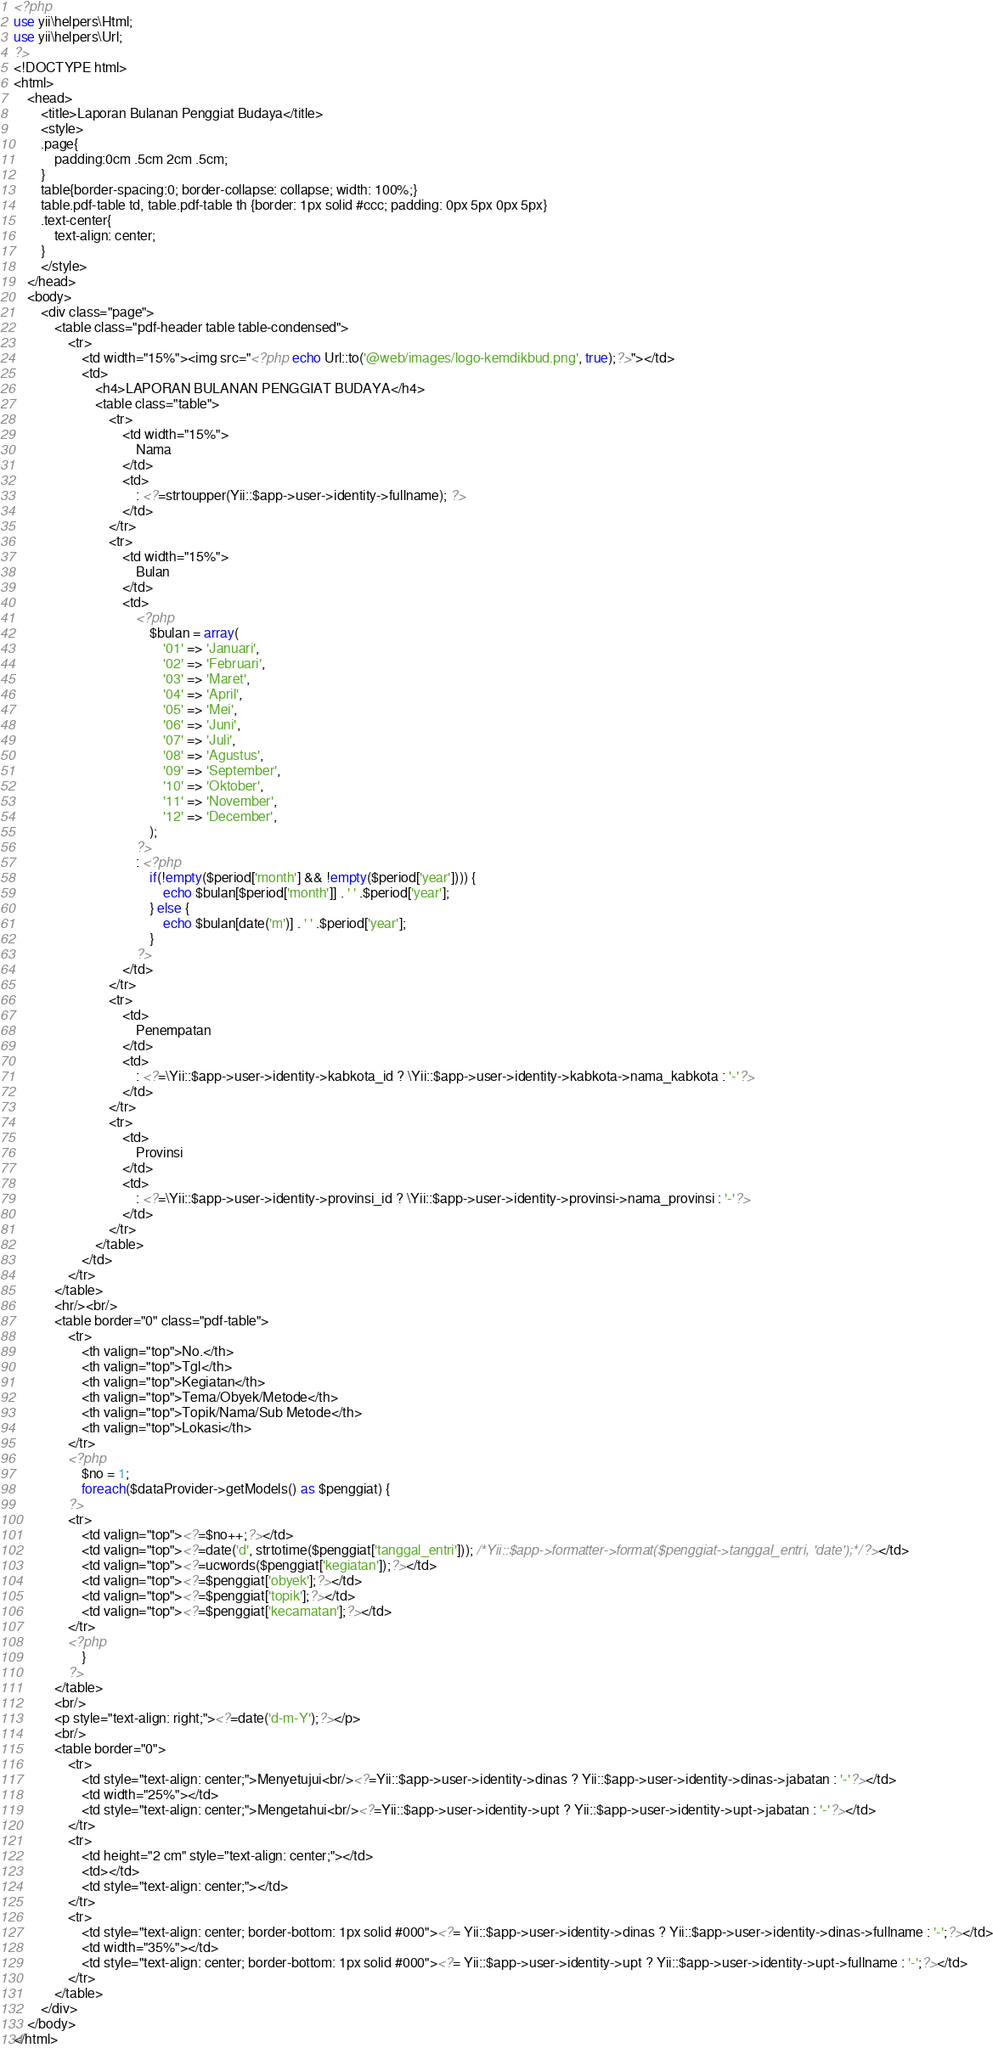Convert code to text. <code><loc_0><loc_0><loc_500><loc_500><_PHP_><?php
use yii\helpers\Html;
use yii\helpers\Url;
?>
<!DOCTYPE html>
<html>
    <head>
        <title>Laporan Bulanan Penggiat Budaya</title>
        <style>
        .page{
            padding:0cm .5cm 2cm .5cm;
        }
        table{border-spacing:0; border-collapse: collapse; width: 100%;}
        table.pdf-table td, table.pdf-table th {border: 1px solid #ccc; padding: 0px 5px 0px 5px}
        .text-center{
            text-align: center;
        }
        </style>
    </head>
    <body>
        <div class="page">
            <table class="pdf-header table table-condensed">
                <tr>
                    <td width="15%"><img src="<?php echo Url::to('@web/images/logo-kemdikbud.png', true);?>"></td>
                    <td>
                        <h4>LAPORAN BULANAN PENGGIAT BUDAYA</h4>
                        <table class="table">
                            <tr>
                                <td width="15%">
                                    Nama
                                </td>
                                <td>
                                    : <?=strtoupper(Yii::$app->user->identity->fullname); ?>
                                </td>
                            </tr>
                            <tr>
                                <td width="15%">
                                    Bulan
                                </td>
                                <td>
                                    <?php
                                        $bulan = array(
                                            '01' => 'Januari',
                                            '02' => 'Februari',
                                            '03' => 'Maret',
                                            '04' => 'April',
                                            '05' => 'Mei',
                                            '06' => 'Juni',
                                            '07' => 'Juli',
                                            '08' => 'Agustus',
                                            '09' => 'September',
                                            '10' => 'Oktober',
                                            '11' => 'November',
                                            '12' => 'December',
                                        );
                                    ?>
                                    : <?php
                                        if(!empty($period['month'] && !empty($period['year']))) {
                                            echo $bulan[$period['month']] . ' ' .$period['year'];
                                        } else {
                                            echo $bulan[date('m')] . ' ' .$period['year'];
                                        }
                                    ?>
                                </td>
                            </tr>
                            <tr>
                                <td>
                                    Penempatan
                                </td>
                                <td>
                                    : <?=\Yii::$app->user->identity->kabkota_id ? \Yii::$app->user->identity->kabkota->nama_kabkota : '-'?>
                                </td>
                            </tr>
                            <tr>
                                <td>
                                    Provinsi
                                </td>
                                <td>
                                    : <?=\Yii::$app->user->identity->provinsi_id ? \Yii::$app->user->identity->provinsi->nama_provinsi : '-'?>
                                </td>
                            </tr>
                        </table>
                    </td>
                </tr>
            </table>
            <hr/><br/>
            <table border="0" class="pdf-table">
                <tr>
                    <th valign="top">No.</th>
                    <th valign="top">Tgl</th>
                    <th valign="top">Kegiatan</th>
                    <th valign="top">Tema/Obyek/Metode</th>
                    <th valign="top">Topik/Nama/Sub Metode</th>
                    <th valign="top">Lokasi</th>
                </tr>
                <?php
                    $no = 1;
                    foreach($dataProvider->getModels() as $penggiat) {
                ?>
                <tr>
                    <td valign="top"><?=$no++;?></td>
                    <td valign="top"><?=date('d', strtotime($penggiat['tanggal_entri'])); /*Yii::$app->formatter->format($penggiat->tanggal_entri, 'date');*/?></td>
                    <td valign="top"><?=ucwords($penggiat['kegiatan']);?></td>
                    <td valign="top"><?=$penggiat['obyek'];?></td>
                    <td valign="top"><?=$penggiat['topik'];?></td>
                    <td valign="top"><?=$penggiat['kecamatan'];?></td>
                </tr>
                <?php
                    }
                ?>
            </table>
            <br/>
            <p style="text-align: right;"><?=date('d-m-Y');?></p>
            <br/>
            <table border="0">
                <tr>
                    <td style="text-align: center;">Menyetujui<br/><?=Yii::$app->user->identity->dinas ? Yii::$app->user->identity->dinas->jabatan : '-'?></td>
                    <td width="25%"></td>
                    <td style="text-align: center;">Mengetahui<br/><?=Yii::$app->user->identity->upt ? Yii::$app->user->identity->upt->jabatan : '-'?></td>
                </tr>
                <tr>
                    <td height="2 cm" style="text-align: center;"></td>
                    <td></td>
                    <td style="text-align: center;"></td>
                </tr>
                <tr>
                    <td style="text-align: center; border-bottom: 1px solid #000"><?= Yii::$app->user->identity->dinas ? Yii::$app->user->identity->dinas->fullname : '-';?></td>
                    <td width="35%"></td>
                    <td style="text-align: center; border-bottom: 1px solid #000"><?= Yii::$app->user->identity->upt ? Yii::$app->user->identity->upt->fullname : '-';?></td>
                </tr>
            </table>
        </div>
    </body>
</html>
</code> 